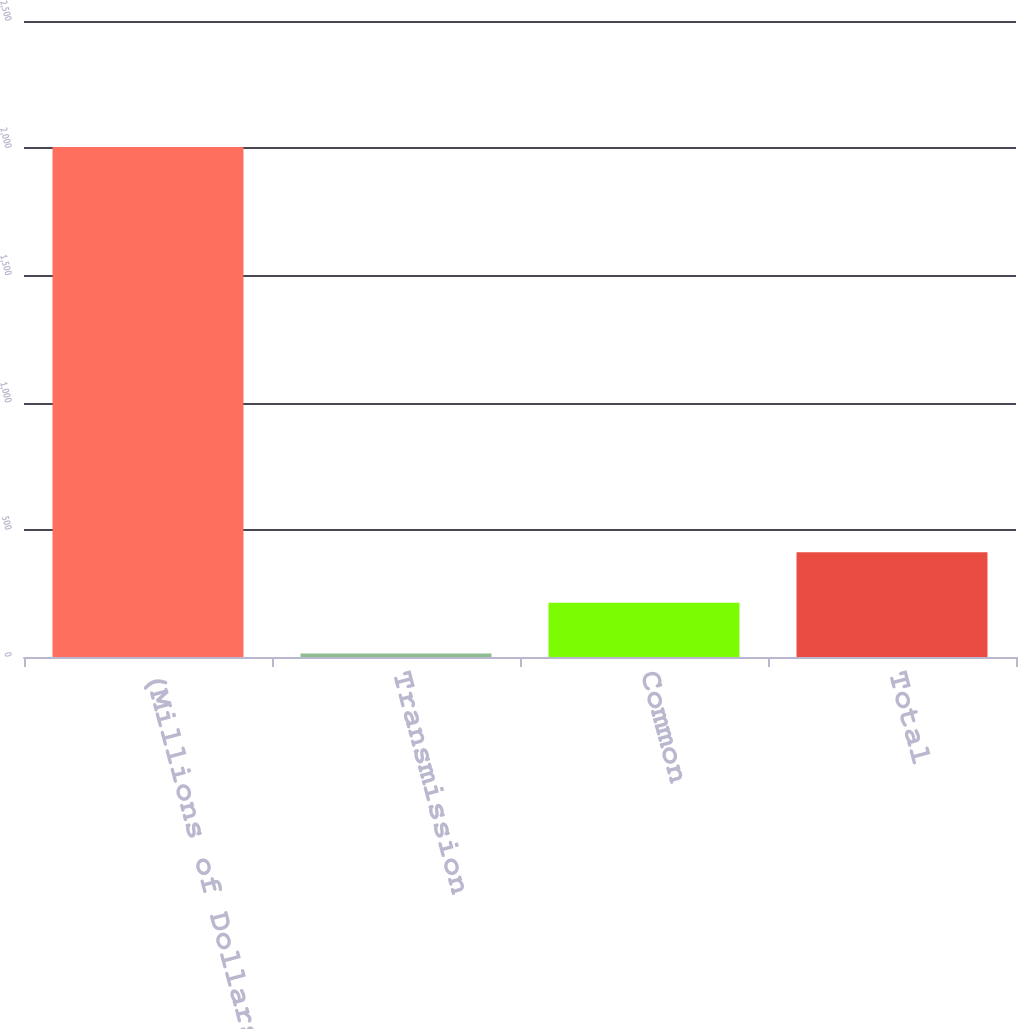<chart> <loc_0><loc_0><loc_500><loc_500><bar_chart><fcel>(Millions of Dollars)<fcel>Transmission<fcel>Common<fcel>Total<nl><fcel>2005<fcel>14<fcel>213.1<fcel>412.2<nl></chart> 